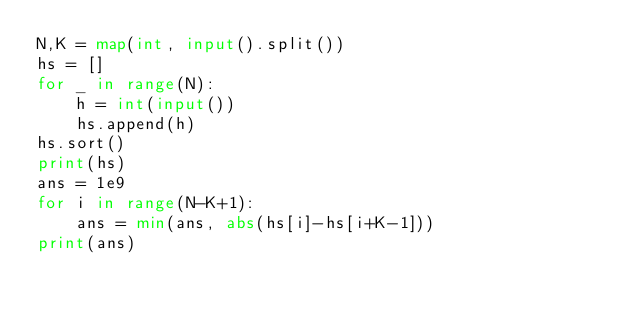<code> <loc_0><loc_0><loc_500><loc_500><_Python_>N,K = map(int, input().split())
hs = []
for _ in range(N):
    h = int(input())
    hs.append(h)
hs.sort()
print(hs)
ans = 1e9
for i in range(N-K+1):
    ans = min(ans, abs(hs[i]-hs[i+K-1]))
print(ans)</code> 